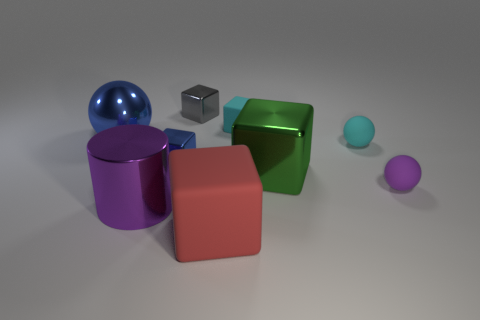Subtract all large blue metal spheres. How many spheres are left? 2 Subtract all green cubes. How many cubes are left? 4 Add 1 cyan objects. How many objects exist? 10 Subtract all cubes. How many objects are left? 4 Subtract 3 cubes. How many cubes are left? 2 Subtract all cyan cylinders. Subtract all yellow spheres. How many cylinders are left? 1 Subtract all blue cylinders. How many cyan balls are left? 1 Subtract 0 yellow cylinders. How many objects are left? 9 Subtract all red matte cylinders. Subtract all tiny things. How many objects are left? 4 Add 5 purple metallic cylinders. How many purple metallic cylinders are left? 6 